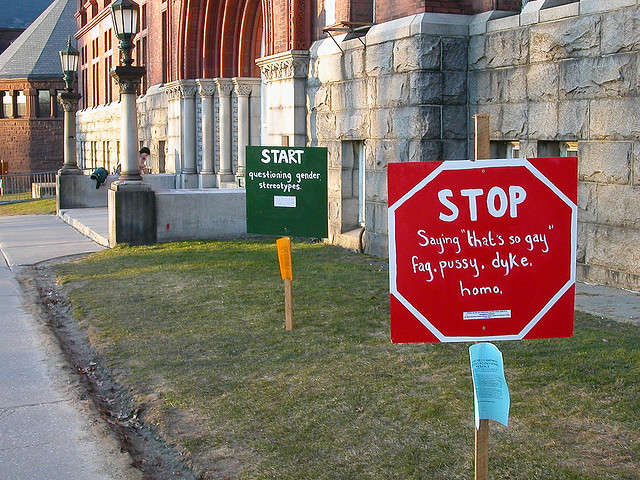Please extract the text content from this image. STRAT questioning gender STOP homo dyke pussy fag gay so that's Saying stereotypes 